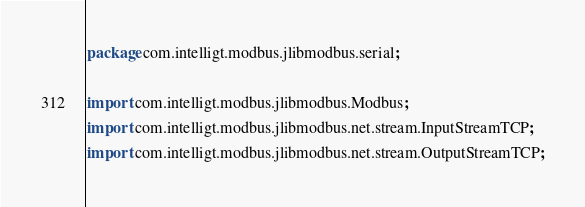<code> <loc_0><loc_0><loc_500><loc_500><_Java_>package com.intelligt.modbus.jlibmodbus.serial;

import com.intelligt.modbus.jlibmodbus.Modbus;
import com.intelligt.modbus.jlibmodbus.net.stream.InputStreamTCP;
import com.intelligt.modbus.jlibmodbus.net.stream.OutputStreamTCP;</code> 